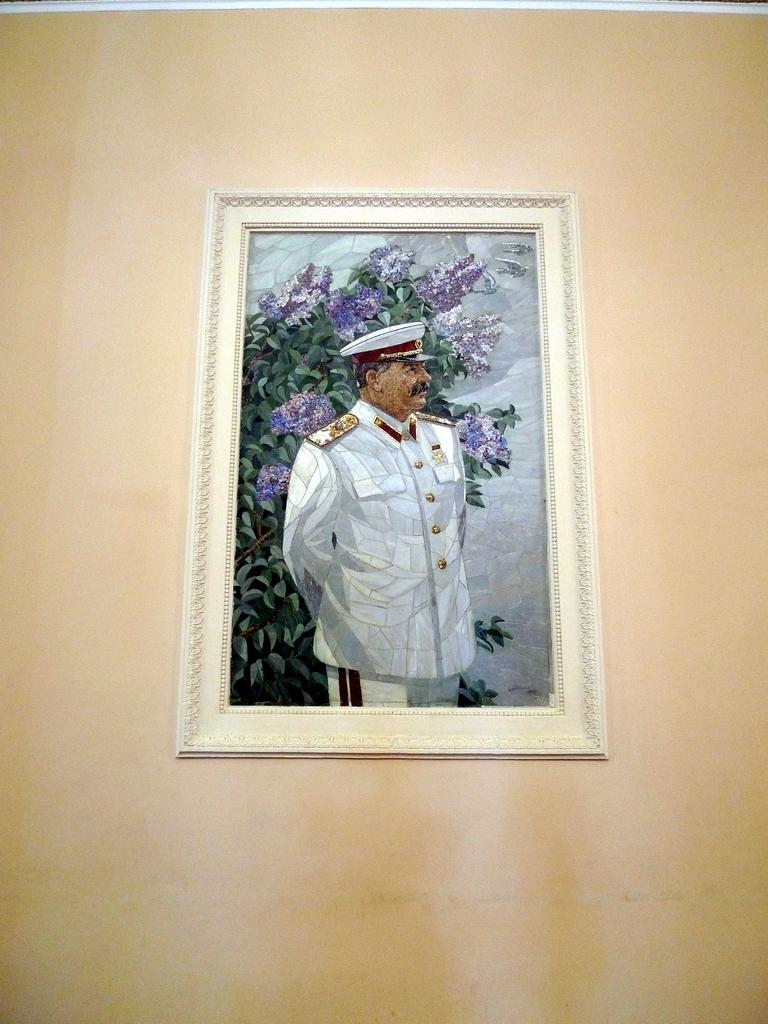What is hanging on the wall in the image? There is a picture with a frame on the wall. Who is in the picture? A man is in the image. What direction is the man looking in the image? The man is looking to the right side of the image. What is the man wearing on his head? The man is wearing a cap. What type of vegetation can be seen in the background of the image? There are leaves and flowers in the background of the image. Can you see the fang of the kitty in the image? There is no kitty or fang present in the image. What type of shade is covering the man in the image? There is no shade covering the man in the image; he is visible in the picture. 